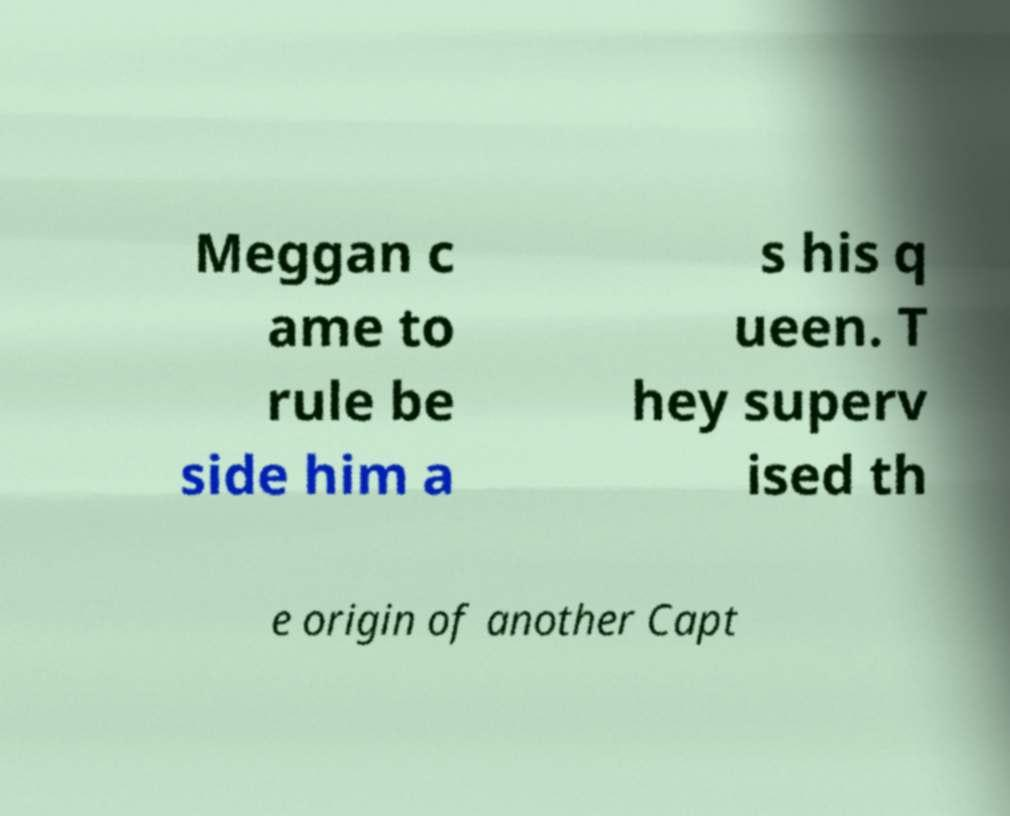Could you extract and type out the text from this image? Meggan c ame to rule be side him a s his q ueen. T hey superv ised th e origin of another Capt 